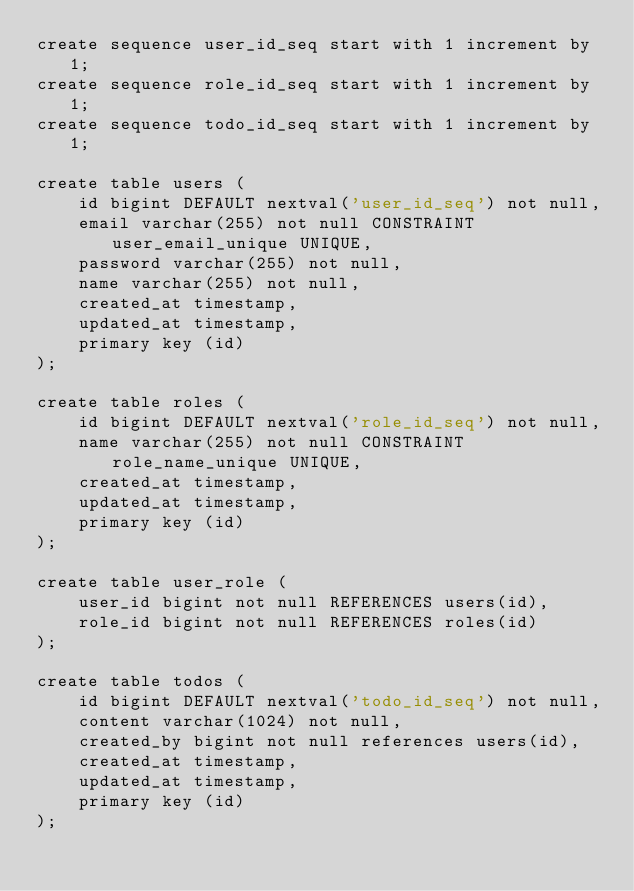<code> <loc_0><loc_0><loc_500><loc_500><_SQL_>create sequence user_id_seq start with 1 increment by 1;
create sequence role_id_seq start with 1 increment by 1;
create sequence todo_id_seq start with 1 increment by 1;

create table users (
    id bigint DEFAULT nextval('user_id_seq') not null,
    email varchar(255) not null CONSTRAINT user_email_unique UNIQUE,
    password varchar(255) not null,
    name varchar(255) not null,
    created_at timestamp,
    updated_at timestamp,
    primary key (id)
);

create table roles (
    id bigint DEFAULT nextval('role_id_seq') not null,
    name varchar(255) not null CONSTRAINT role_name_unique UNIQUE,
    created_at timestamp,
    updated_at timestamp,
    primary key (id)
);

create table user_role (
    user_id bigint not null REFERENCES users(id),
    role_id bigint not null REFERENCES roles(id)
);

create table todos (
    id bigint DEFAULT nextval('todo_id_seq') not null,
    content varchar(1024) not null,
    created_by bigint not null references users(id),
    created_at timestamp,
    updated_at timestamp,
    primary key (id)
);
</code> 